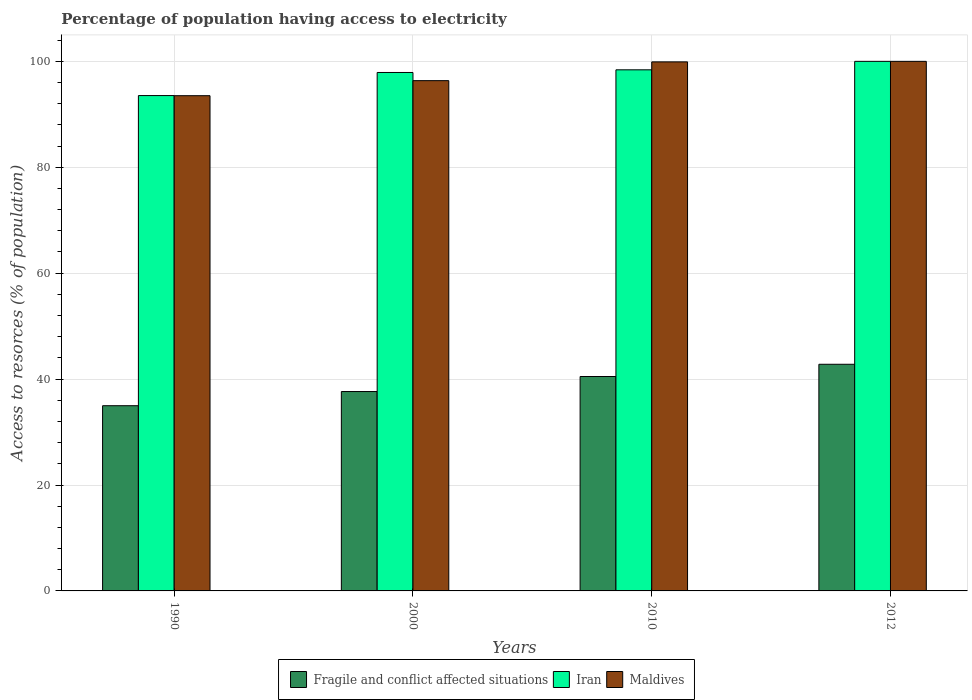How many bars are there on the 4th tick from the left?
Offer a very short reply. 3. In how many cases, is the number of bars for a given year not equal to the number of legend labels?
Keep it short and to the point. 0. What is the percentage of population having access to electricity in Iran in 2010?
Your response must be concise. 98.4. Across all years, what is the maximum percentage of population having access to electricity in Iran?
Provide a short and direct response. 100. Across all years, what is the minimum percentage of population having access to electricity in Fragile and conflict affected situations?
Provide a succinct answer. 34.97. In which year was the percentage of population having access to electricity in Maldives maximum?
Offer a terse response. 2012. In which year was the percentage of population having access to electricity in Fragile and conflict affected situations minimum?
Your response must be concise. 1990. What is the total percentage of population having access to electricity in Iran in the graph?
Provide a succinct answer. 389.84. What is the difference between the percentage of population having access to electricity in Iran in 2010 and that in 2012?
Provide a succinct answer. -1.6. What is the difference between the percentage of population having access to electricity in Iran in 2000 and the percentage of population having access to electricity in Maldives in 1990?
Provide a short and direct response. 4.38. What is the average percentage of population having access to electricity in Maldives per year?
Keep it short and to the point. 97.44. In the year 1990, what is the difference between the percentage of population having access to electricity in Fragile and conflict affected situations and percentage of population having access to electricity in Maldives?
Ensure brevity in your answer.  -58.54. In how many years, is the percentage of population having access to electricity in Fragile and conflict affected situations greater than 20 %?
Provide a short and direct response. 4. What is the ratio of the percentage of population having access to electricity in Iran in 2000 to that in 2012?
Provide a short and direct response. 0.98. Is the percentage of population having access to electricity in Fragile and conflict affected situations in 1990 less than that in 2012?
Your answer should be very brief. Yes. Is the difference between the percentage of population having access to electricity in Fragile and conflict affected situations in 1990 and 2000 greater than the difference between the percentage of population having access to electricity in Maldives in 1990 and 2000?
Provide a succinct answer. Yes. What is the difference between the highest and the second highest percentage of population having access to electricity in Iran?
Ensure brevity in your answer.  1.6. What is the difference between the highest and the lowest percentage of population having access to electricity in Maldives?
Your response must be concise. 6.48. What does the 3rd bar from the left in 2010 represents?
Your response must be concise. Maldives. What does the 1st bar from the right in 2012 represents?
Give a very brief answer. Maldives. Are all the bars in the graph horizontal?
Give a very brief answer. No. How many years are there in the graph?
Ensure brevity in your answer.  4. Does the graph contain any zero values?
Provide a succinct answer. No. Where does the legend appear in the graph?
Provide a short and direct response. Bottom center. How many legend labels are there?
Give a very brief answer. 3. What is the title of the graph?
Ensure brevity in your answer.  Percentage of population having access to electricity. What is the label or title of the Y-axis?
Offer a very short reply. Access to resorces (% of population). What is the Access to resorces (% of population) in Fragile and conflict affected situations in 1990?
Provide a short and direct response. 34.97. What is the Access to resorces (% of population) of Iran in 1990?
Your answer should be very brief. 93.54. What is the Access to resorces (% of population) in Maldives in 1990?
Your answer should be compact. 93.52. What is the Access to resorces (% of population) in Fragile and conflict affected situations in 2000?
Your answer should be compact. 37.65. What is the Access to resorces (% of population) of Iran in 2000?
Provide a succinct answer. 97.9. What is the Access to resorces (% of population) in Maldives in 2000?
Your response must be concise. 96.36. What is the Access to resorces (% of population) of Fragile and conflict affected situations in 2010?
Offer a very short reply. 40.49. What is the Access to resorces (% of population) in Iran in 2010?
Provide a succinct answer. 98.4. What is the Access to resorces (% of population) in Maldives in 2010?
Keep it short and to the point. 99.9. What is the Access to resorces (% of population) in Fragile and conflict affected situations in 2012?
Your response must be concise. 42.8. What is the Access to resorces (% of population) of Iran in 2012?
Give a very brief answer. 100. What is the Access to resorces (% of population) in Maldives in 2012?
Keep it short and to the point. 100. Across all years, what is the maximum Access to resorces (% of population) in Fragile and conflict affected situations?
Your response must be concise. 42.8. Across all years, what is the maximum Access to resorces (% of population) in Iran?
Keep it short and to the point. 100. Across all years, what is the maximum Access to resorces (% of population) in Maldives?
Your answer should be compact. 100. Across all years, what is the minimum Access to resorces (% of population) in Fragile and conflict affected situations?
Provide a short and direct response. 34.97. Across all years, what is the minimum Access to resorces (% of population) of Iran?
Offer a very short reply. 93.54. Across all years, what is the minimum Access to resorces (% of population) in Maldives?
Make the answer very short. 93.52. What is the total Access to resorces (% of population) in Fragile and conflict affected situations in the graph?
Ensure brevity in your answer.  155.91. What is the total Access to resorces (% of population) of Iran in the graph?
Your answer should be compact. 389.84. What is the total Access to resorces (% of population) of Maldives in the graph?
Provide a short and direct response. 389.77. What is the difference between the Access to resorces (% of population) of Fragile and conflict affected situations in 1990 and that in 2000?
Give a very brief answer. -2.68. What is the difference between the Access to resorces (% of population) in Iran in 1990 and that in 2000?
Provide a short and direct response. -4.36. What is the difference between the Access to resorces (% of population) of Maldives in 1990 and that in 2000?
Keep it short and to the point. -2.84. What is the difference between the Access to resorces (% of population) of Fragile and conflict affected situations in 1990 and that in 2010?
Your answer should be very brief. -5.51. What is the difference between the Access to resorces (% of population) of Iran in 1990 and that in 2010?
Ensure brevity in your answer.  -4.86. What is the difference between the Access to resorces (% of population) of Maldives in 1990 and that in 2010?
Your answer should be very brief. -6.38. What is the difference between the Access to resorces (% of population) of Fragile and conflict affected situations in 1990 and that in 2012?
Provide a short and direct response. -7.83. What is the difference between the Access to resorces (% of population) of Iran in 1990 and that in 2012?
Ensure brevity in your answer.  -6.46. What is the difference between the Access to resorces (% of population) in Maldives in 1990 and that in 2012?
Ensure brevity in your answer.  -6.48. What is the difference between the Access to resorces (% of population) of Fragile and conflict affected situations in 2000 and that in 2010?
Provide a short and direct response. -2.84. What is the difference between the Access to resorces (% of population) of Maldives in 2000 and that in 2010?
Offer a terse response. -3.54. What is the difference between the Access to resorces (% of population) of Fragile and conflict affected situations in 2000 and that in 2012?
Provide a short and direct response. -5.15. What is the difference between the Access to resorces (% of population) in Maldives in 2000 and that in 2012?
Your response must be concise. -3.64. What is the difference between the Access to resorces (% of population) in Fragile and conflict affected situations in 2010 and that in 2012?
Offer a very short reply. -2.31. What is the difference between the Access to resorces (% of population) in Maldives in 2010 and that in 2012?
Your answer should be very brief. -0.1. What is the difference between the Access to resorces (% of population) of Fragile and conflict affected situations in 1990 and the Access to resorces (% of population) of Iran in 2000?
Your response must be concise. -62.93. What is the difference between the Access to resorces (% of population) in Fragile and conflict affected situations in 1990 and the Access to resorces (% of population) in Maldives in 2000?
Your answer should be compact. -61.38. What is the difference between the Access to resorces (% of population) of Iran in 1990 and the Access to resorces (% of population) of Maldives in 2000?
Make the answer very short. -2.82. What is the difference between the Access to resorces (% of population) in Fragile and conflict affected situations in 1990 and the Access to resorces (% of population) in Iran in 2010?
Offer a terse response. -63.43. What is the difference between the Access to resorces (% of population) in Fragile and conflict affected situations in 1990 and the Access to resorces (% of population) in Maldives in 2010?
Make the answer very short. -64.93. What is the difference between the Access to resorces (% of population) in Iran in 1990 and the Access to resorces (% of population) in Maldives in 2010?
Your answer should be very brief. -6.36. What is the difference between the Access to resorces (% of population) in Fragile and conflict affected situations in 1990 and the Access to resorces (% of population) in Iran in 2012?
Provide a succinct answer. -65.03. What is the difference between the Access to resorces (% of population) of Fragile and conflict affected situations in 1990 and the Access to resorces (% of population) of Maldives in 2012?
Your response must be concise. -65.03. What is the difference between the Access to resorces (% of population) of Iran in 1990 and the Access to resorces (% of population) of Maldives in 2012?
Keep it short and to the point. -6.46. What is the difference between the Access to resorces (% of population) of Fragile and conflict affected situations in 2000 and the Access to resorces (% of population) of Iran in 2010?
Provide a succinct answer. -60.75. What is the difference between the Access to resorces (% of population) of Fragile and conflict affected situations in 2000 and the Access to resorces (% of population) of Maldives in 2010?
Make the answer very short. -62.25. What is the difference between the Access to resorces (% of population) in Fragile and conflict affected situations in 2000 and the Access to resorces (% of population) in Iran in 2012?
Your response must be concise. -62.35. What is the difference between the Access to resorces (% of population) in Fragile and conflict affected situations in 2000 and the Access to resorces (% of population) in Maldives in 2012?
Give a very brief answer. -62.35. What is the difference between the Access to resorces (% of population) of Iran in 2000 and the Access to resorces (% of population) of Maldives in 2012?
Ensure brevity in your answer.  -2.1. What is the difference between the Access to resorces (% of population) of Fragile and conflict affected situations in 2010 and the Access to resorces (% of population) of Iran in 2012?
Offer a very short reply. -59.51. What is the difference between the Access to resorces (% of population) in Fragile and conflict affected situations in 2010 and the Access to resorces (% of population) in Maldives in 2012?
Provide a succinct answer. -59.51. What is the difference between the Access to resorces (% of population) in Iran in 2010 and the Access to resorces (% of population) in Maldives in 2012?
Offer a terse response. -1.6. What is the average Access to resorces (% of population) in Fragile and conflict affected situations per year?
Offer a terse response. 38.98. What is the average Access to resorces (% of population) of Iran per year?
Your answer should be very brief. 97.46. What is the average Access to resorces (% of population) in Maldives per year?
Give a very brief answer. 97.44. In the year 1990, what is the difference between the Access to resorces (% of population) in Fragile and conflict affected situations and Access to resorces (% of population) in Iran?
Keep it short and to the point. -58.57. In the year 1990, what is the difference between the Access to resorces (% of population) in Fragile and conflict affected situations and Access to resorces (% of population) in Maldives?
Your answer should be very brief. -58.54. In the year 1990, what is the difference between the Access to resorces (% of population) in Iran and Access to resorces (% of population) in Maldives?
Ensure brevity in your answer.  0.02. In the year 2000, what is the difference between the Access to resorces (% of population) in Fragile and conflict affected situations and Access to resorces (% of population) in Iran?
Offer a very short reply. -60.25. In the year 2000, what is the difference between the Access to resorces (% of population) of Fragile and conflict affected situations and Access to resorces (% of population) of Maldives?
Ensure brevity in your answer.  -58.71. In the year 2000, what is the difference between the Access to resorces (% of population) in Iran and Access to resorces (% of population) in Maldives?
Make the answer very short. 1.54. In the year 2010, what is the difference between the Access to resorces (% of population) in Fragile and conflict affected situations and Access to resorces (% of population) in Iran?
Ensure brevity in your answer.  -57.91. In the year 2010, what is the difference between the Access to resorces (% of population) in Fragile and conflict affected situations and Access to resorces (% of population) in Maldives?
Provide a short and direct response. -59.41. In the year 2010, what is the difference between the Access to resorces (% of population) of Iran and Access to resorces (% of population) of Maldives?
Make the answer very short. -1.5. In the year 2012, what is the difference between the Access to resorces (% of population) in Fragile and conflict affected situations and Access to resorces (% of population) in Iran?
Provide a short and direct response. -57.2. In the year 2012, what is the difference between the Access to resorces (% of population) in Fragile and conflict affected situations and Access to resorces (% of population) in Maldives?
Your answer should be compact. -57.2. In the year 2012, what is the difference between the Access to resorces (% of population) in Iran and Access to resorces (% of population) in Maldives?
Ensure brevity in your answer.  0. What is the ratio of the Access to resorces (% of population) in Fragile and conflict affected situations in 1990 to that in 2000?
Keep it short and to the point. 0.93. What is the ratio of the Access to resorces (% of population) of Iran in 1990 to that in 2000?
Your answer should be very brief. 0.96. What is the ratio of the Access to resorces (% of population) in Maldives in 1990 to that in 2000?
Offer a very short reply. 0.97. What is the ratio of the Access to resorces (% of population) in Fragile and conflict affected situations in 1990 to that in 2010?
Offer a terse response. 0.86. What is the ratio of the Access to resorces (% of population) of Iran in 1990 to that in 2010?
Ensure brevity in your answer.  0.95. What is the ratio of the Access to resorces (% of population) of Maldives in 1990 to that in 2010?
Your answer should be compact. 0.94. What is the ratio of the Access to resorces (% of population) in Fragile and conflict affected situations in 1990 to that in 2012?
Keep it short and to the point. 0.82. What is the ratio of the Access to resorces (% of population) of Iran in 1990 to that in 2012?
Give a very brief answer. 0.94. What is the ratio of the Access to resorces (% of population) of Maldives in 1990 to that in 2012?
Give a very brief answer. 0.94. What is the ratio of the Access to resorces (% of population) of Fragile and conflict affected situations in 2000 to that in 2010?
Your answer should be compact. 0.93. What is the ratio of the Access to resorces (% of population) in Maldives in 2000 to that in 2010?
Provide a short and direct response. 0.96. What is the ratio of the Access to resorces (% of population) in Fragile and conflict affected situations in 2000 to that in 2012?
Give a very brief answer. 0.88. What is the ratio of the Access to resorces (% of population) of Iran in 2000 to that in 2012?
Make the answer very short. 0.98. What is the ratio of the Access to resorces (% of population) in Maldives in 2000 to that in 2012?
Keep it short and to the point. 0.96. What is the ratio of the Access to resorces (% of population) in Fragile and conflict affected situations in 2010 to that in 2012?
Offer a terse response. 0.95. What is the difference between the highest and the second highest Access to resorces (% of population) of Fragile and conflict affected situations?
Offer a very short reply. 2.31. What is the difference between the highest and the second highest Access to resorces (% of population) in Iran?
Your answer should be very brief. 1.6. What is the difference between the highest and the second highest Access to resorces (% of population) in Maldives?
Ensure brevity in your answer.  0.1. What is the difference between the highest and the lowest Access to resorces (% of population) in Fragile and conflict affected situations?
Offer a terse response. 7.83. What is the difference between the highest and the lowest Access to resorces (% of population) of Iran?
Your response must be concise. 6.46. What is the difference between the highest and the lowest Access to resorces (% of population) of Maldives?
Your answer should be compact. 6.48. 